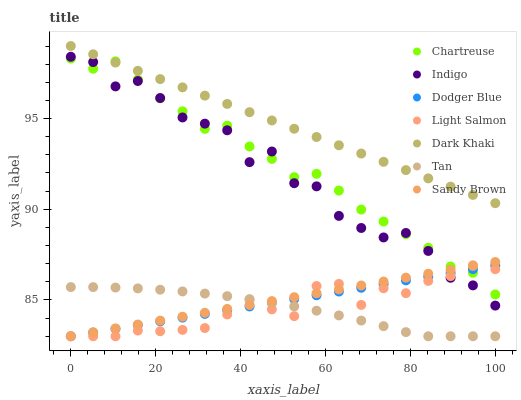Does Tan have the minimum area under the curve?
Answer yes or no. Yes. Does Dark Khaki have the maximum area under the curve?
Answer yes or no. Yes. Does Indigo have the minimum area under the curve?
Answer yes or no. No. Does Indigo have the maximum area under the curve?
Answer yes or no. No. Is Dark Khaki the smoothest?
Answer yes or no. Yes. Is Indigo the roughest?
Answer yes or no. Yes. Is Indigo the smoothest?
Answer yes or no. No. Is Dark Khaki the roughest?
Answer yes or no. No. Does Light Salmon have the lowest value?
Answer yes or no. Yes. Does Indigo have the lowest value?
Answer yes or no. No. Does Dark Khaki have the highest value?
Answer yes or no. Yes. Does Indigo have the highest value?
Answer yes or no. No. Is Tan less than Indigo?
Answer yes or no. Yes. Is Dark Khaki greater than Tan?
Answer yes or no. Yes. Does Light Salmon intersect Indigo?
Answer yes or no. Yes. Is Light Salmon less than Indigo?
Answer yes or no. No. Is Light Salmon greater than Indigo?
Answer yes or no. No. Does Tan intersect Indigo?
Answer yes or no. No. 